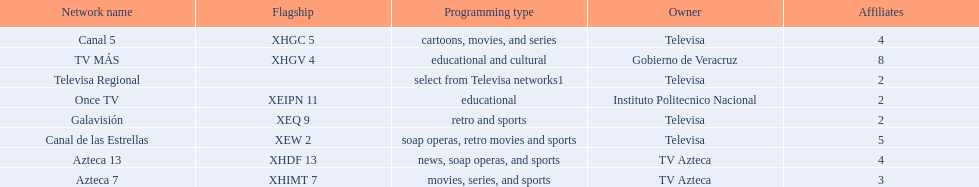Which owner has the most networks? Televisa. 